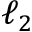<formula> <loc_0><loc_0><loc_500><loc_500>\ell _ { 2 }</formula> 